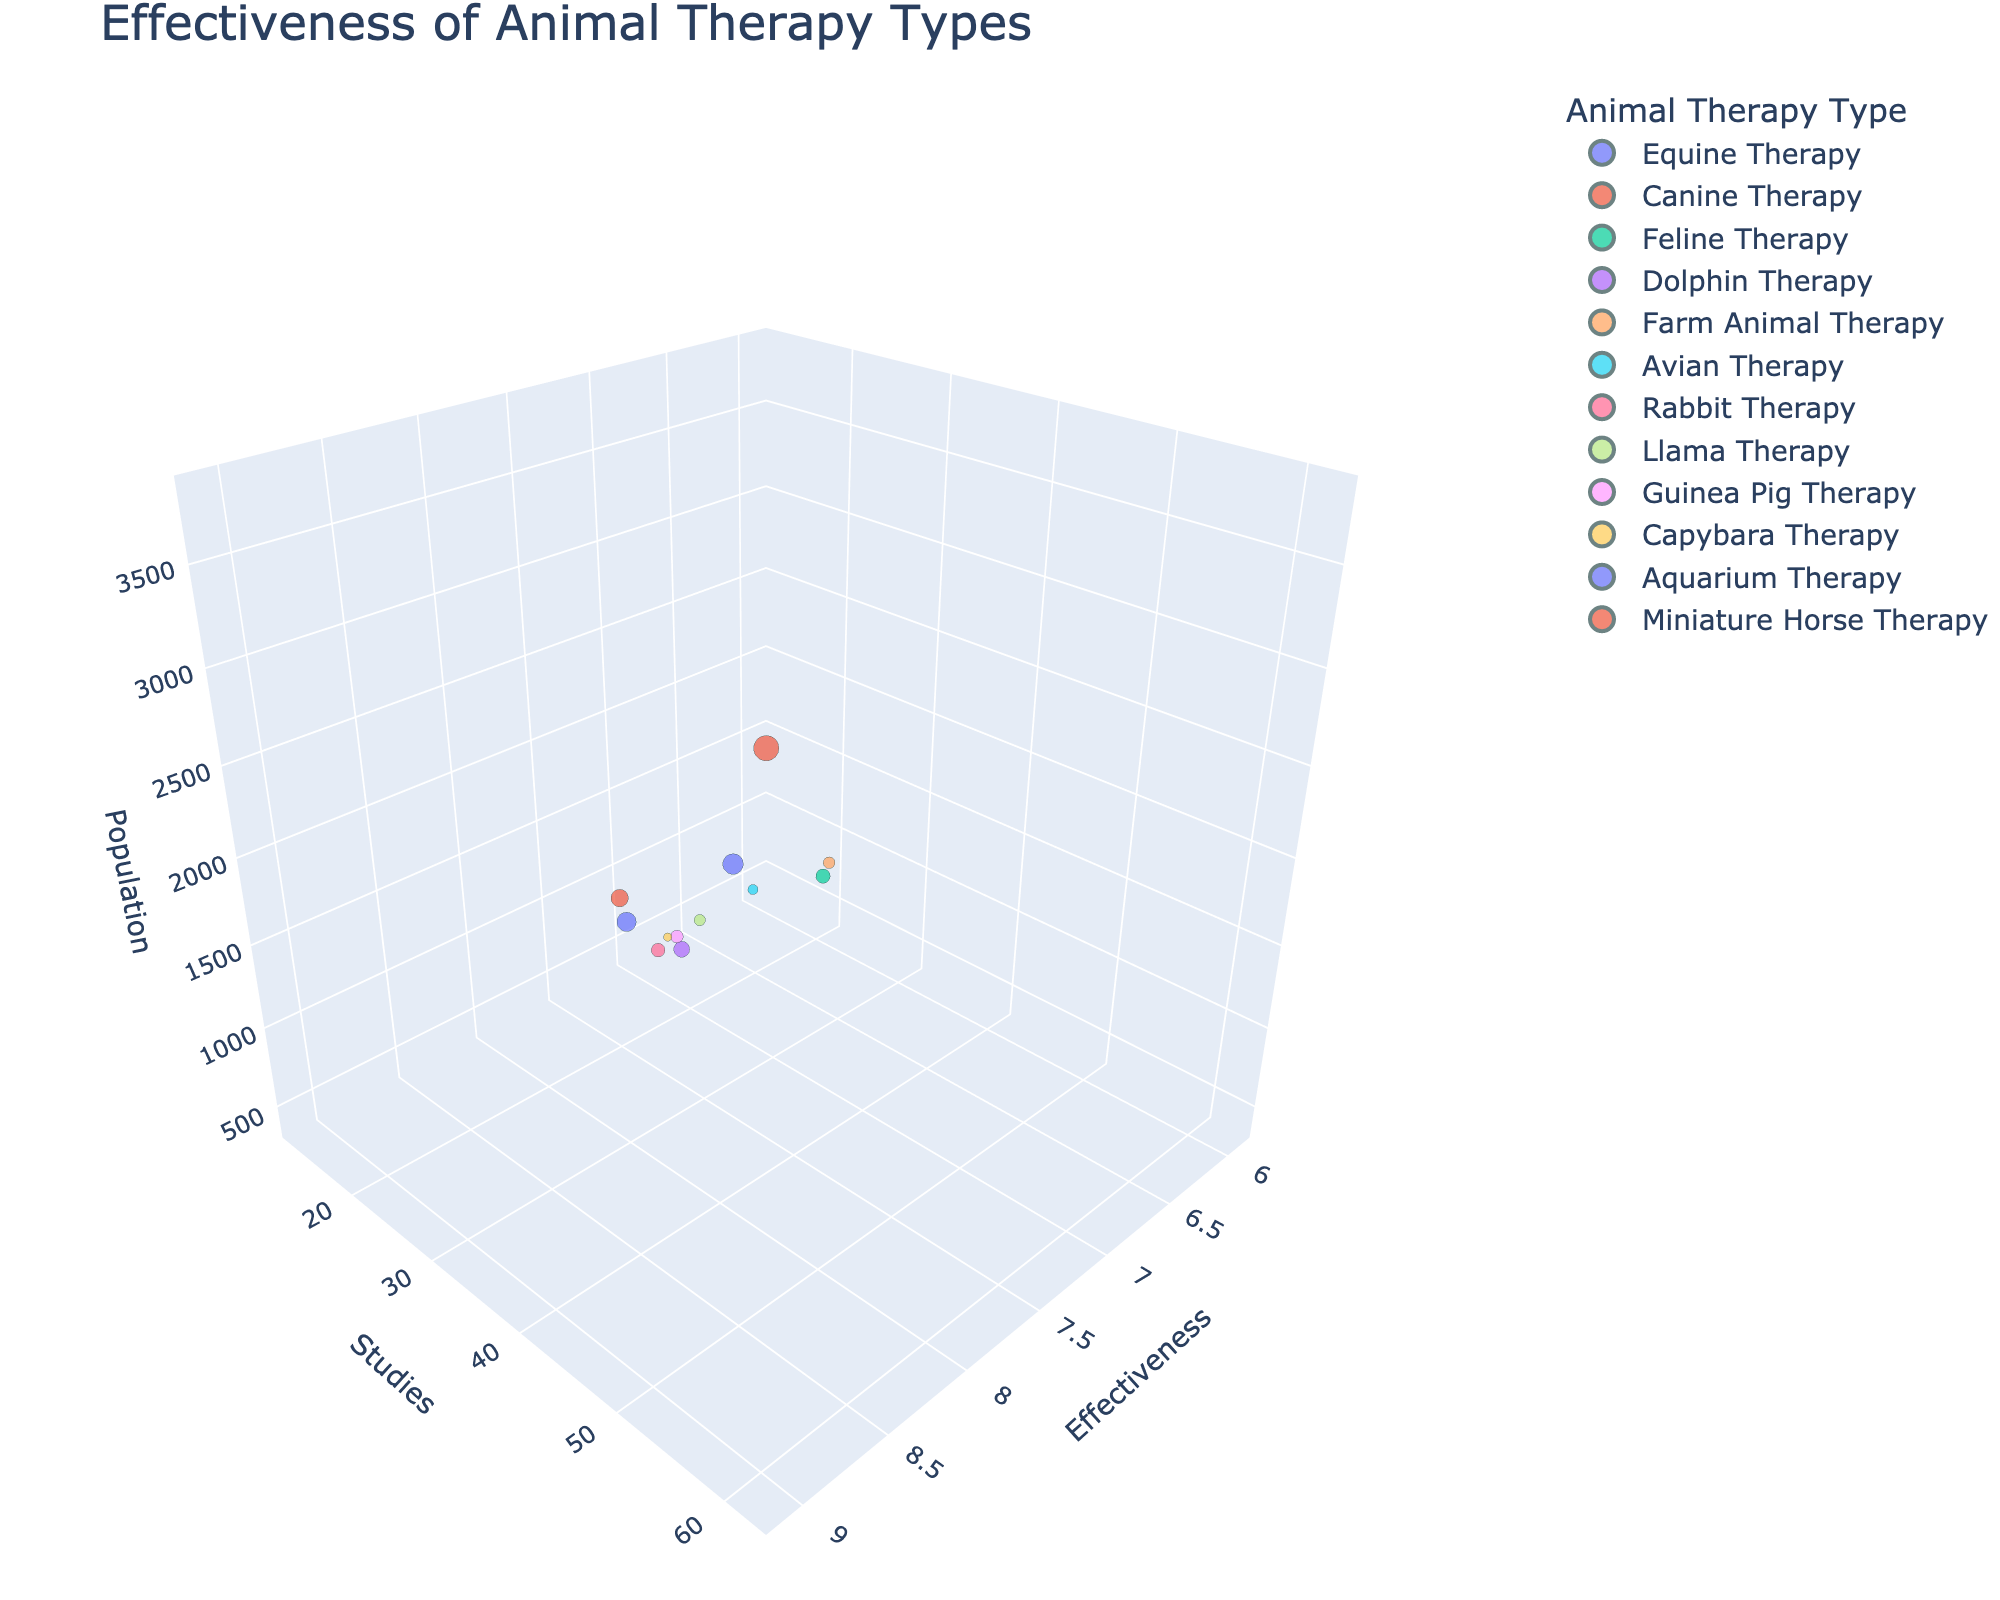What is the title of the figure? The title is prominently displayed at the top of the chart. It summarizes the subject and the type of insights provided by the figure.
Answer: Effectiveness of Animal Therapy Types Which animal therapy type has the highest effectiveness score? By examining the x-axis and identifying the bubble that is farthest to the right, we can determine the type of therapy with the highest effectiveness score.
Answer: Canine Therapy How many animal therapy types have effectiveness scores above 8.0? Identify all bubbles with x-axis positions greater than 8.0 and count them.
Answer: 5 Which mental health condition has the largest population size studied? Look at the z-axis positions of the bubbles and identify the one that's the highest, then check its corresponding mental health condition.
Answer: Anxiety What is the average number of studies conducted for depression and anxiety? Locate the bubbles for depression and anxiety, note their y-axis positions for the number of studies, add them up, and divide by 2. For depression (45) and anxiety (62), the sum is 107, so the average is 107/2.
Answer: 53.5 Which therapy type is associated with the most studies? Find the bubble that is highest on the y-axis and look at its corresponding therapy type.
Answer: Canine Therapy Do any therapy types for PTSD and OCD have a similar effectiveness score? Compare the x-axis positions of the bubbles for PTSD and OCD to see if they are close. For PTSD (6.5) and OCD (7.2), they are not very close but somewhat similar.
Answer: Yes, they are somewhat similar Which animal therapy type has the smallest population size studied? Identify the bubble that is lowest on the z-axis and check its corresponding animal therapy type.
Answer: Capybara Therapy Are there more animal therapy types with effectiveness scores below or above 7? Count the number of bubbles to the left and right of the x-axis position 7. Below are 4 (PTSD, Schizophrenia, Avian Therapy, Capybara Therapy) and above are 8.
Answer: More above 7 Which mental health condition seems to benefit most from animal therapy based on population size and effectiveness score? Identify bubbles with high z-axis and x-axis positions. Anxiety has the highest effectiveness (9.1) and large population size (3800).
Answer: Anxiety 